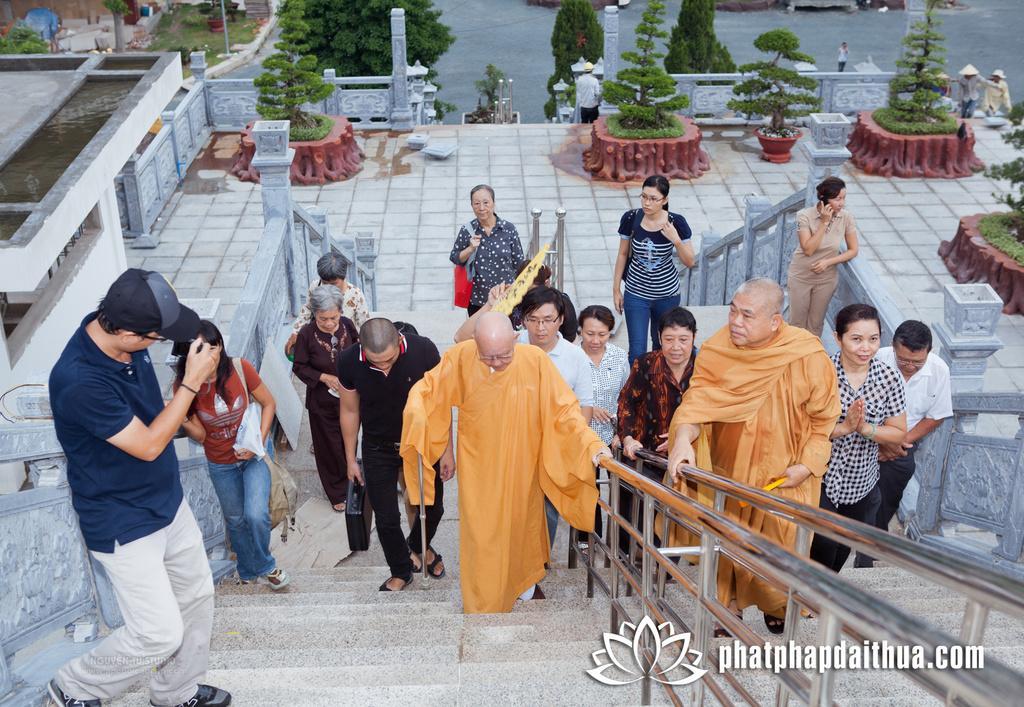Could you give a brief overview of what you see in this image? In this image, we can see a group of people are on the stairs. Few are holding some objects. Here we can see railings, rods and watermark in the image. Top of the image, we can see plants, wall, pole, few people, pillars and some objects. 